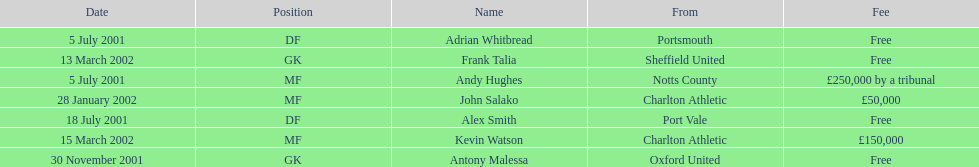Andy huges and adrian whitbread both tranfered on which date? 5 July 2001. 